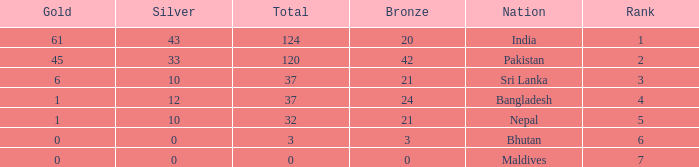How much Silver has a Rank of 7? 1.0. 